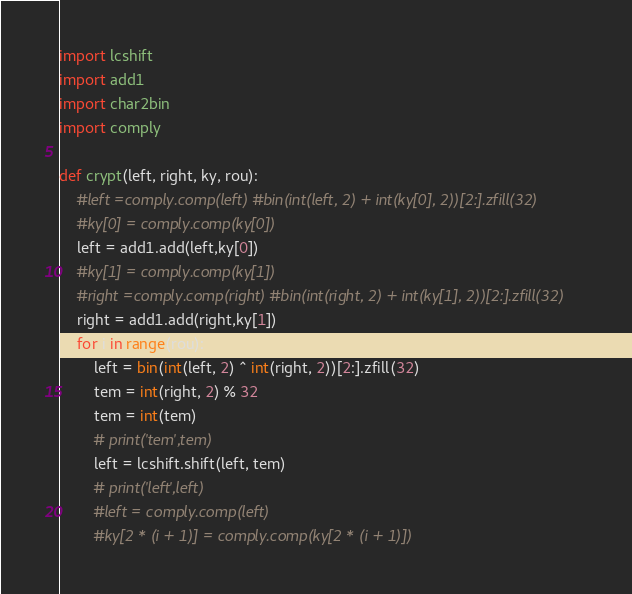<code> <loc_0><loc_0><loc_500><loc_500><_Python_>import lcshift
import add1
import char2bin
import comply

def crypt(left, right, ky, rou):
    #left =comply.comp(left) #bin(int(left, 2) + int(ky[0], 2))[2:].zfill(32)
    #ky[0] = comply.comp(ky[0])
    left = add1.add(left,ky[0])
    #ky[1] = comply.comp(ky[1])
    #right =comply.comp(right) #bin(int(right, 2) + int(ky[1], 2))[2:].zfill(32)
    right = add1.add(right,ky[1])
    for i in range(rou):
        left = bin(int(left, 2) ^ int(right, 2))[2:].zfill(32)
        tem = int(right, 2) % 32
        tem = int(tem)
        # print('tem',tem)
        left = lcshift.shift(left, tem)
        # print('left',left)
        #left = comply.comp(left)
        #ky[2 * (i + 1)] = comply.comp(ky[2 * (i + 1)])</code> 